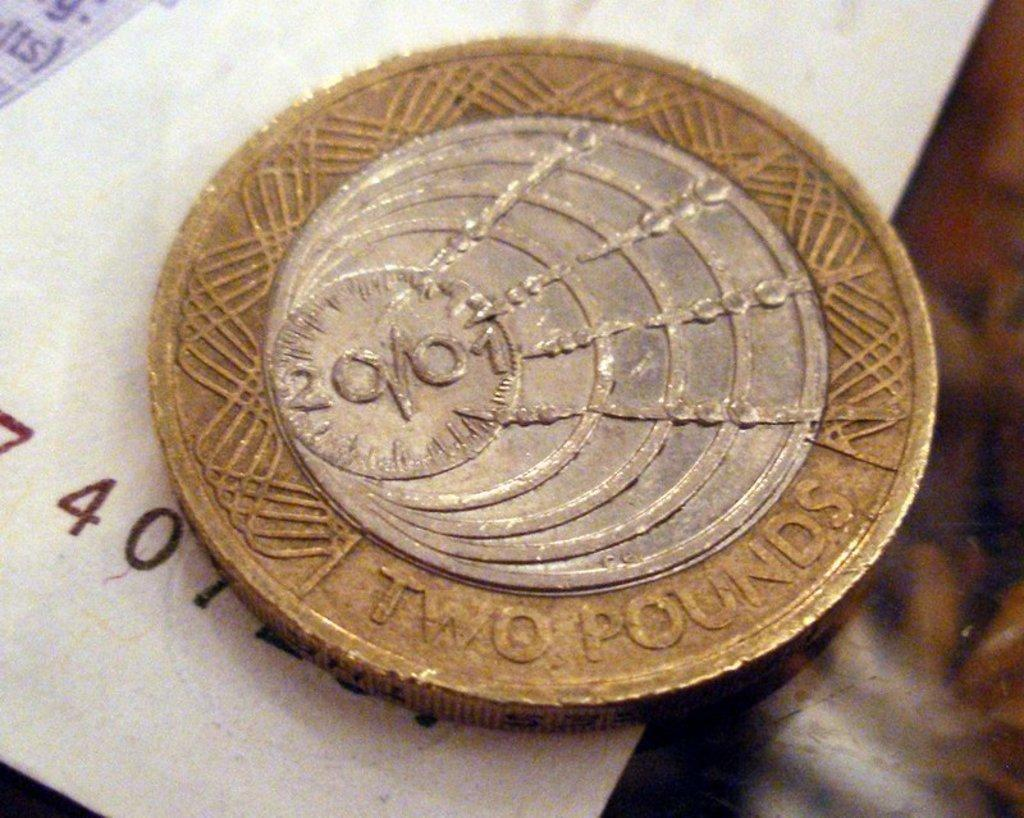<image>
Share a concise interpretation of the image provided. a two pound coin is laying on a piece of paper 